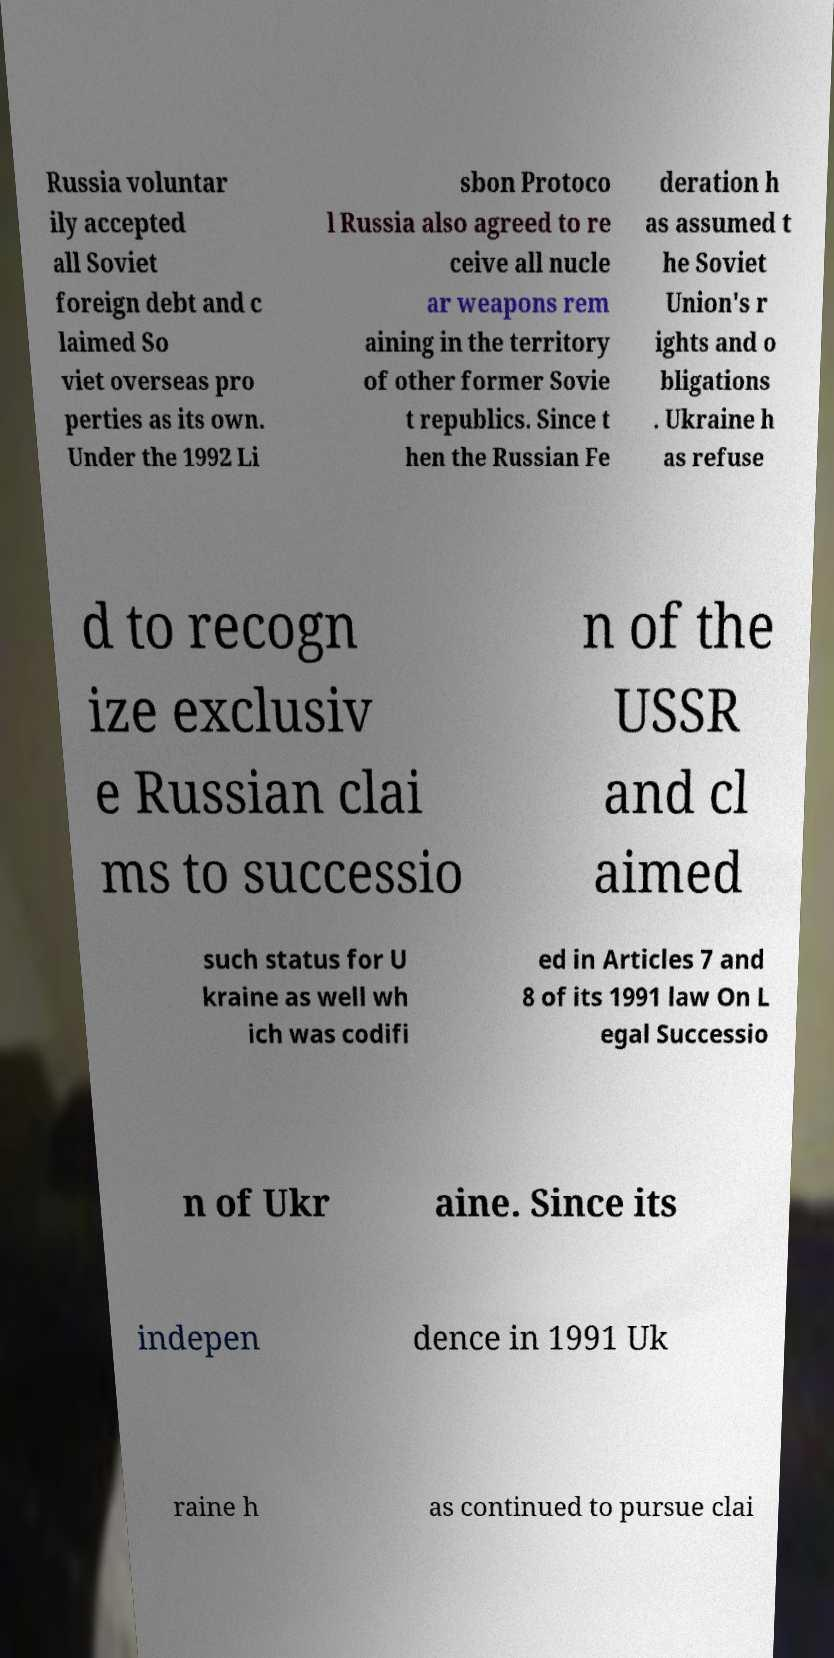I need the written content from this picture converted into text. Can you do that? Russia voluntar ily accepted all Soviet foreign debt and c laimed So viet overseas pro perties as its own. Under the 1992 Li sbon Protoco l Russia also agreed to re ceive all nucle ar weapons rem aining in the territory of other former Sovie t republics. Since t hen the Russian Fe deration h as assumed t he Soviet Union's r ights and o bligations . Ukraine h as refuse d to recogn ize exclusiv e Russian clai ms to successio n of the USSR and cl aimed such status for U kraine as well wh ich was codifi ed in Articles 7 and 8 of its 1991 law On L egal Successio n of Ukr aine. Since its indepen dence in 1991 Uk raine h as continued to pursue clai 